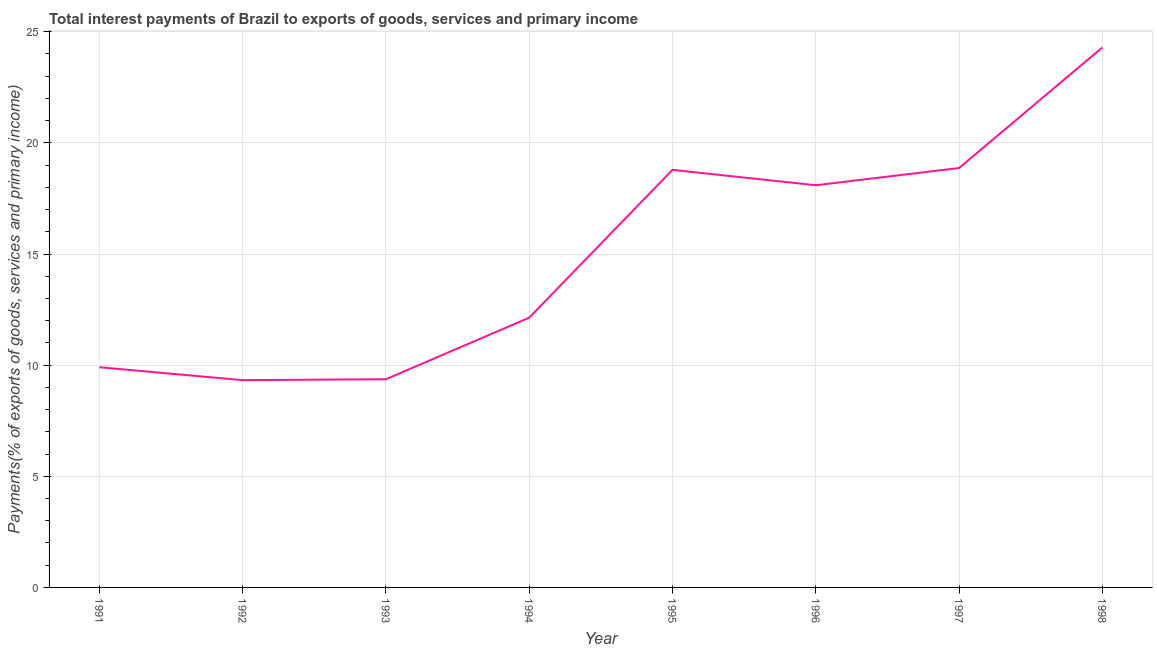What is the total interest payments on external debt in 1993?
Provide a short and direct response. 9.37. Across all years, what is the maximum total interest payments on external debt?
Make the answer very short. 24.29. Across all years, what is the minimum total interest payments on external debt?
Your response must be concise. 9.33. What is the sum of the total interest payments on external debt?
Your response must be concise. 120.78. What is the difference between the total interest payments on external debt in 1991 and 1996?
Offer a very short reply. -8.19. What is the average total interest payments on external debt per year?
Ensure brevity in your answer.  15.1. What is the median total interest payments on external debt?
Ensure brevity in your answer.  15.12. In how many years, is the total interest payments on external debt greater than 2 %?
Ensure brevity in your answer.  8. What is the ratio of the total interest payments on external debt in 1995 to that in 1996?
Ensure brevity in your answer.  1.04. Is the total interest payments on external debt in 1992 less than that in 1996?
Ensure brevity in your answer.  Yes. What is the difference between the highest and the second highest total interest payments on external debt?
Your answer should be compact. 5.42. What is the difference between the highest and the lowest total interest payments on external debt?
Ensure brevity in your answer.  14.97. How many lines are there?
Provide a short and direct response. 1. What is the difference between two consecutive major ticks on the Y-axis?
Give a very brief answer. 5. What is the title of the graph?
Provide a short and direct response. Total interest payments of Brazil to exports of goods, services and primary income. What is the label or title of the X-axis?
Keep it short and to the point. Year. What is the label or title of the Y-axis?
Provide a short and direct response. Payments(% of exports of goods, services and primary income). What is the Payments(% of exports of goods, services and primary income) in 1991?
Provide a short and direct response. 9.91. What is the Payments(% of exports of goods, services and primary income) in 1992?
Offer a very short reply. 9.33. What is the Payments(% of exports of goods, services and primary income) of 1993?
Your answer should be compact. 9.37. What is the Payments(% of exports of goods, services and primary income) in 1994?
Make the answer very short. 12.14. What is the Payments(% of exports of goods, services and primary income) of 1995?
Provide a short and direct response. 18.79. What is the Payments(% of exports of goods, services and primary income) of 1996?
Give a very brief answer. 18.1. What is the Payments(% of exports of goods, services and primary income) of 1997?
Keep it short and to the point. 18.87. What is the Payments(% of exports of goods, services and primary income) of 1998?
Your response must be concise. 24.29. What is the difference between the Payments(% of exports of goods, services and primary income) in 1991 and 1992?
Ensure brevity in your answer.  0.58. What is the difference between the Payments(% of exports of goods, services and primary income) in 1991 and 1993?
Offer a very short reply. 0.54. What is the difference between the Payments(% of exports of goods, services and primary income) in 1991 and 1994?
Make the answer very short. -2.23. What is the difference between the Payments(% of exports of goods, services and primary income) in 1991 and 1995?
Your answer should be compact. -8.88. What is the difference between the Payments(% of exports of goods, services and primary income) in 1991 and 1996?
Your response must be concise. -8.19. What is the difference between the Payments(% of exports of goods, services and primary income) in 1991 and 1997?
Provide a short and direct response. -8.96. What is the difference between the Payments(% of exports of goods, services and primary income) in 1991 and 1998?
Your answer should be compact. -14.39. What is the difference between the Payments(% of exports of goods, services and primary income) in 1992 and 1993?
Provide a short and direct response. -0.04. What is the difference between the Payments(% of exports of goods, services and primary income) in 1992 and 1994?
Provide a succinct answer. -2.81. What is the difference between the Payments(% of exports of goods, services and primary income) in 1992 and 1995?
Offer a very short reply. -9.46. What is the difference between the Payments(% of exports of goods, services and primary income) in 1992 and 1996?
Ensure brevity in your answer.  -8.77. What is the difference between the Payments(% of exports of goods, services and primary income) in 1992 and 1997?
Offer a terse response. -9.54. What is the difference between the Payments(% of exports of goods, services and primary income) in 1992 and 1998?
Give a very brief answer. -14.97. What is the difference between the Payments(% of exports of goods, services and primary income) in 1993 and 1994?
Provide a short and direct response. -2.77. What is the difference between the Payments(% of exports of goods, services and primary income) in 1993 and 1995?
Provide a short and direct response. -9.42. What is the difference between the Payments(% of exports of goods, services and primary income) in 1993 and 1996?
Give a very brief answer. -8.73. What is the difference between the Payments(% of exports of goods, services and primary income) in 1993 and 1997?
Provide a succinct answer. -9.5. What is the difference between the Payments(% of exports of goods, services and primary income) in 1993 and 1998?
Your response must be concise. -14.93. What is the difference between the Payments(% of exports of goods, services and primary income) in 1994 and 1995?
Make the answer very short. -6.65. What is the difference between the Payments(% of exports of goods, services and primary income) in 1994 and 1996?
Offer a terse response. -5.96. What is the difference between the Payments(% of exports of goods, services and primary income) in 1994 and 1997?
Keep it short and to the point. -6.73. What is the difference between the Payments(% of exports of goods, services and primary income) in 1994 and 1998?
Your answer should be very brief. -12.16. What is the difference between the Payments(% of exports of goods, services and primary income) in 1995 and 1996?
Your answer should be very brief. 0.69. What is the difference between the Payments(% of exports of goods, services and primary income) in 1995 and 1997?
Your answer should be compact. -0.08. What is the difference between the Payments(% of exports of goods, services and primary income) in 1995 and 1998?
Offer a terse response. -5.51. What is the difference between the Payments(% of exports of goods, services and primary income) in 1996 and 1997?
Offer a very short reply. -0.78. What is the difference between the Payments(% of exports of goods, services and primary income) in 1996 and 1998?
Your response must be concise. -6.2. What is the difference between the Payments(% of exports of goods, services and primary income) in 1997 and 1998?
Ensure brevity in your answer.  -5.42. What is the ratio of the Payments(% of exports of goods, services and primary income) in 1991 to that in 1992?
Provide a short and direct response. 1.06. What is the ratio of the Payments(% of exports of goods, services and primary income) in 1991 to that in 1993?
Your answer should be compact. 1.06. What is the ratio of the Payments(% of exports of goods, services and primary income) in 1991 to that in 1994?
Give a very brief answer. 0.82. What is the ratio of the Payments(% of exports of goods, services and primary income) in 1991 to that in 1995?
Your answer should be compact. 0.53. What is the ratio of the Payments(% of exports of goods, services and primary income) in 1991 to that in 1996?
Provide a short and direct response. 0.55. What is the ratio of the Payments(% of exports of goods, services and primary income) in 1991 to that in 1997?
Keep it short and to the point. 0.53. What is the ratio of the Payments(% of exports of goods, services and primary income) in 1991 to that in 1998?
Offer a terse response. 0.41. What is the ratio of the Payments(% of exports of goods, services and primary income) in 1992 to that in 1993?
Provide a short and direct response. 1. What is the ratio of the Payments(% of exports of goods, services and primary income) in 1992 to that in 1994?
Your answer should be compact. 0.77. What is the ratio of the Payments(% of exports of goods, services and primary income) in 1992 to that in 1995?
Ensure brevity in your answer.  0.5. What is the ratio of the Payments(% of exports of goods, services and primary income) in 1992 to that in 1996?
Keep it short and to the point. 0.52. What is the ratio of the Payments(% of exports of goods, services and primary income) in 1992 to that in 1997?
Offer a terse response. 0.49. What is the ratio of the Payments(% of exports of goods, services and primary income) in 1992 to that in 1998?
Your answer should be very brief. 0.38. What is the ratio of the Payments(% of exports of goods, services and primary income) in 1993 to that in 1994?
Your response must be concise. 0.77. What is the ratio of the Payments(% of exports of goods, services and primary income) in 1993 to that in 1995?
Your answer should be compact. 0.5. What is the ratio of the Payments(% of exports of goods, services and primary income) in 1993 to that in 1996?
Provide a short and direct response. 0.52. What is the ratio of the Payments(% of exports of goods, services and primary income) in 1993 to that in 1997?
Your response must be concise. 0.5. What is the ratio of the Payments(% of exports of goods, services and primary income) in 1993 to that in 1998?
Your response must be concise. 0.39. What is the ratio of the Payments(% of exports of goods, services and primary income) in 1994 to that in 1995?
Ensure brevity in your answer.  0.65. What is the ratio of the Payments(% of exports of goods, services and primary income) in 1994 to that in 1996?
Keep it short and to the point. 0.67. What is the ratio of the Payments(% of exports of goods, services and primary income) in 1994 to that in 1997?
Give a very brief answer. 0.64. What is the ratio of the Payments(% of exports of goods, services and primary income) in 1994 to that in 1998?
Your answer should be compact. 0.5. What is the ratio of the Payments(% of exports of goods, services and primary income) in 1995 to that in 1996?
Offer a terse response. 1.04. What is the ratio of the Payments(% of exports of goods, services and primary income) in 1995 to that in 1997?
Your answer should be compact. 1. What is the ratio of the Payments(% of exports of goods, services and primary income) in 1995 to that in 1998?
Your response must be concise. 0.77. What is the ratio of the Payments(% of exports of goods, services and primary income) in 1996 to that in 1997?
Give a very brief answer. 0.96. What is the ratio of the Payments(% of exports of goods, services and primary income) in 1996 to that in 1998?
Your answer should be very brief. 0.74. What is the ratio of the Payments(% of exports of goods, services and primary income) in 1997 to that in 1998?
Offer a very short reply. 0.78. 